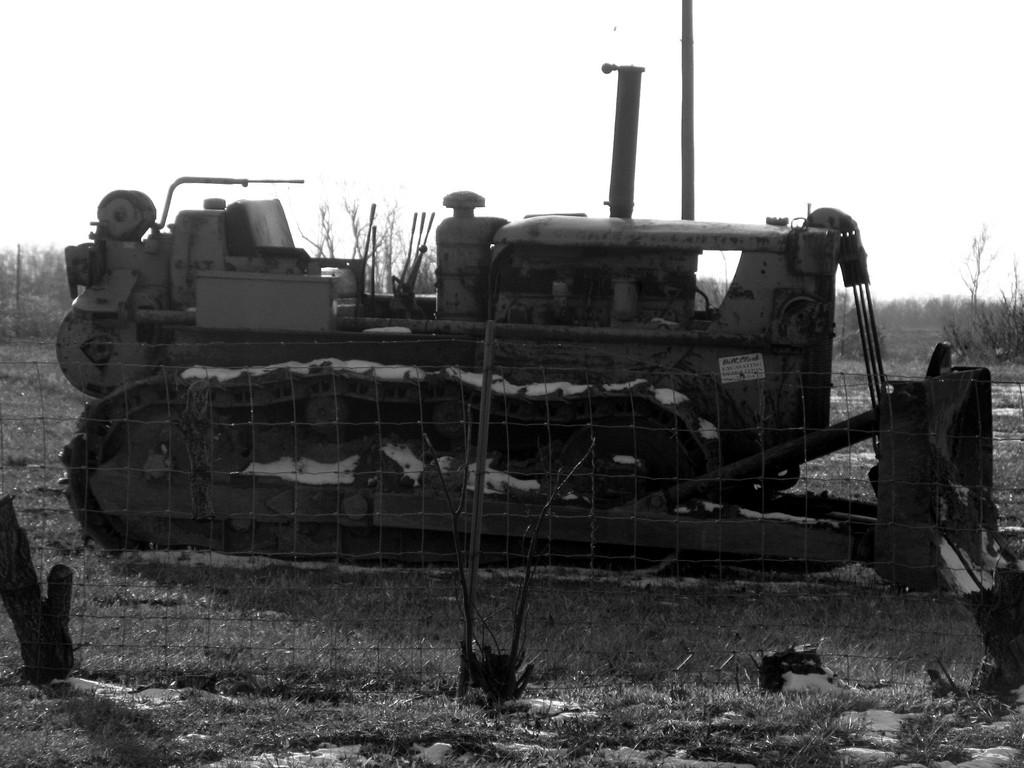What is the color scheme of the image? The image is black and white. What is located in the foreground of the image? There is a vehicle and net fencing in the foreground of the image. What can be seen in the background of the image? There are trees and the sky visible in the background of the image. What brand of toothpaste is advertised on the vehicle in the image? There is no toothpaste or advertisement present on the vehicle in the image. What is your opinion on the image? As an AI, I do not have personal opinions, but I can describe the image based on the provided facts. 